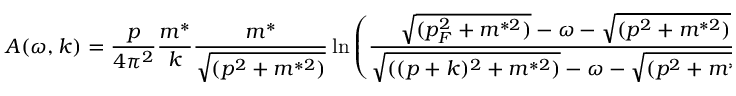Convert formula to latex. <formula><loc_0><loc_0><loc_500><loc_500>A ( \omega , k ) = \frac { p } { 4 \pi ^ { 2 } } \frac { m ^ { * } } { k } \frac { m ^ { * } } { \sqrt { ( p ^ { 2 } + m ^ { * 2 } ) } } \ln \left ( \frac { \sqrt { ( p _ { F } ^ { 2 } + m ^ { * 2 } ) } - \omega - \sqrt { ( p ^ { 2 } + m ^ { * 2 } ) } } { \sqrt { ( ( p + k ) ^ { 2 } + m ^ { * 2 } ) } - \omega - \sqrt { ( p ^ { 2 } + m ^ { * 2 } ) } } \right ) ,</formula> 